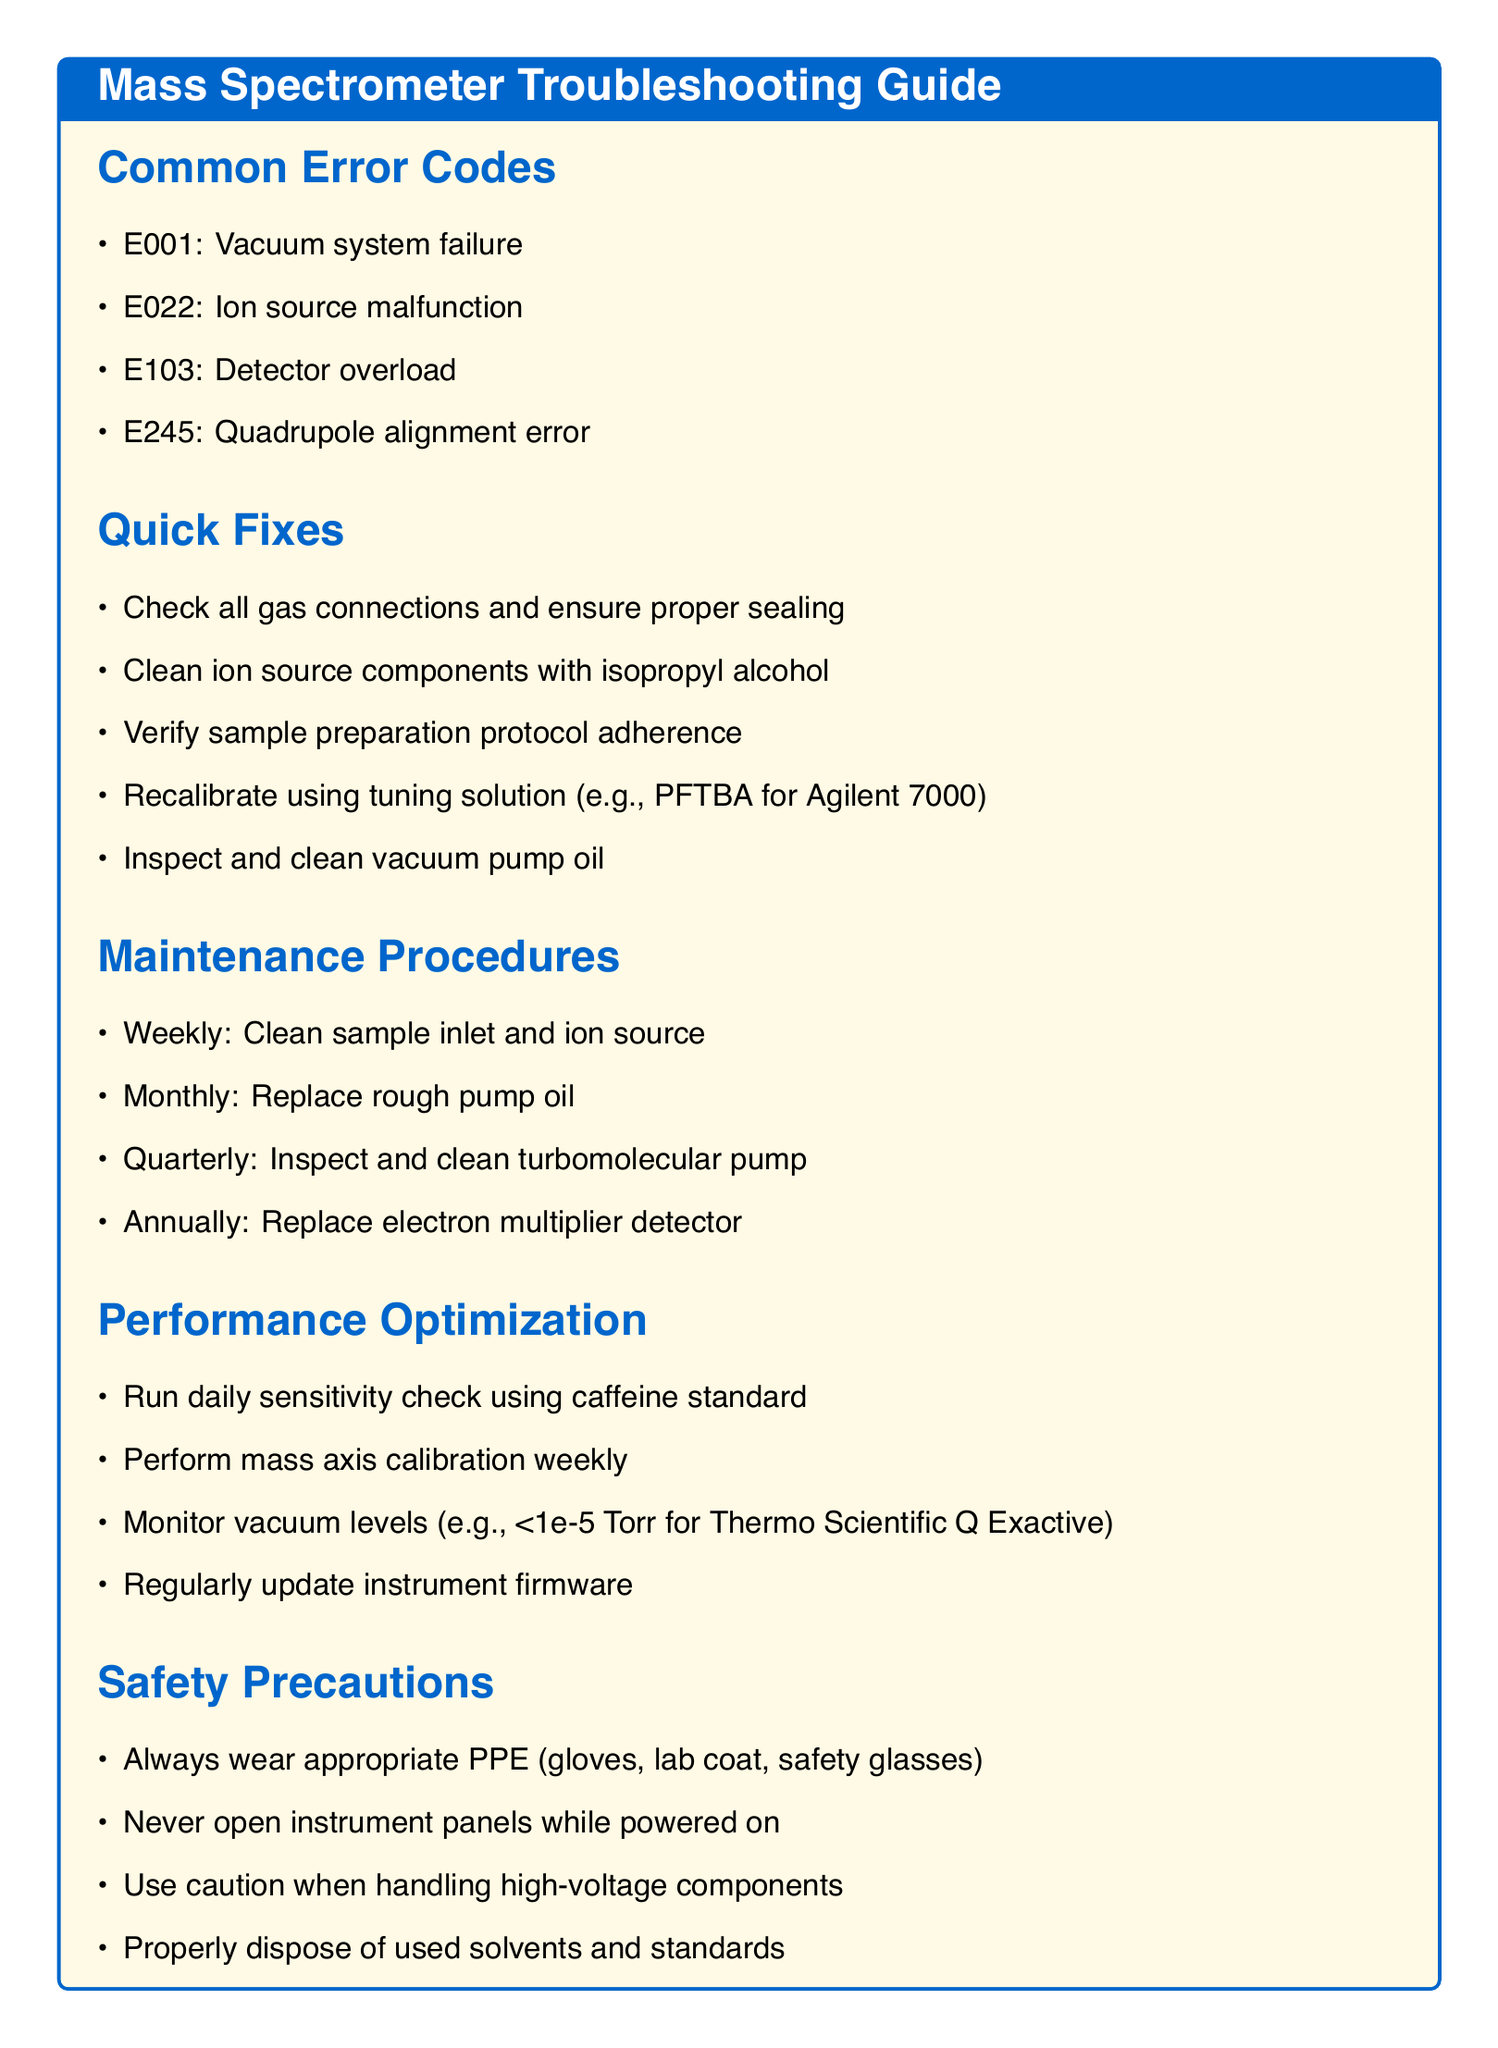what is the error code for vacuum system failure? The error codes section lists various codes, including E001 which corresponds to a vacuum system failure.
Answer: E001 how often should rough pump oil be replaced? The maintenance procedures specify that rough pump oil should be replaced monthly.
Answer: Monthly what cleaning solution is recommended for ion source components? The quick fixes section recommends cleaning ion source components with isopropyl alcohol.
Answer: isopropyl alcohol what preventive action is suggested to monitor vacuum levels? The performance optimization section mentions monitoring vacuum levels as a crucial preventive action.
Answer: Monitor vacuum levels what type of personal protective equipment is always recommended? The safety precautions section emphasizes wearing appropriate PPE, which includes gloves, lab coat, and safety glasses.
Answer: gloves, lab coat, safety glasses which error code refers to an ion source malfunction? Among the common error codes, E022 refers specifically to an ion source malfunction.
Answer: E022 how frequently should the sample inlet and ion source be cleaned? The maintenance procedures indicate that the sample inlet and ion source should be cleaned weekly.
Answer: Weekly what is used for daily sensitivity checks? The performance optimization section states that caffeine standard is used for daily sensitivity checks.
Answer: caffeine standard what is the annual maintenance procedure for the detector? The maintenance procedures specify that the electron multiplier detector should be replaced annually.
Answer: Replace electron multiplier detector 